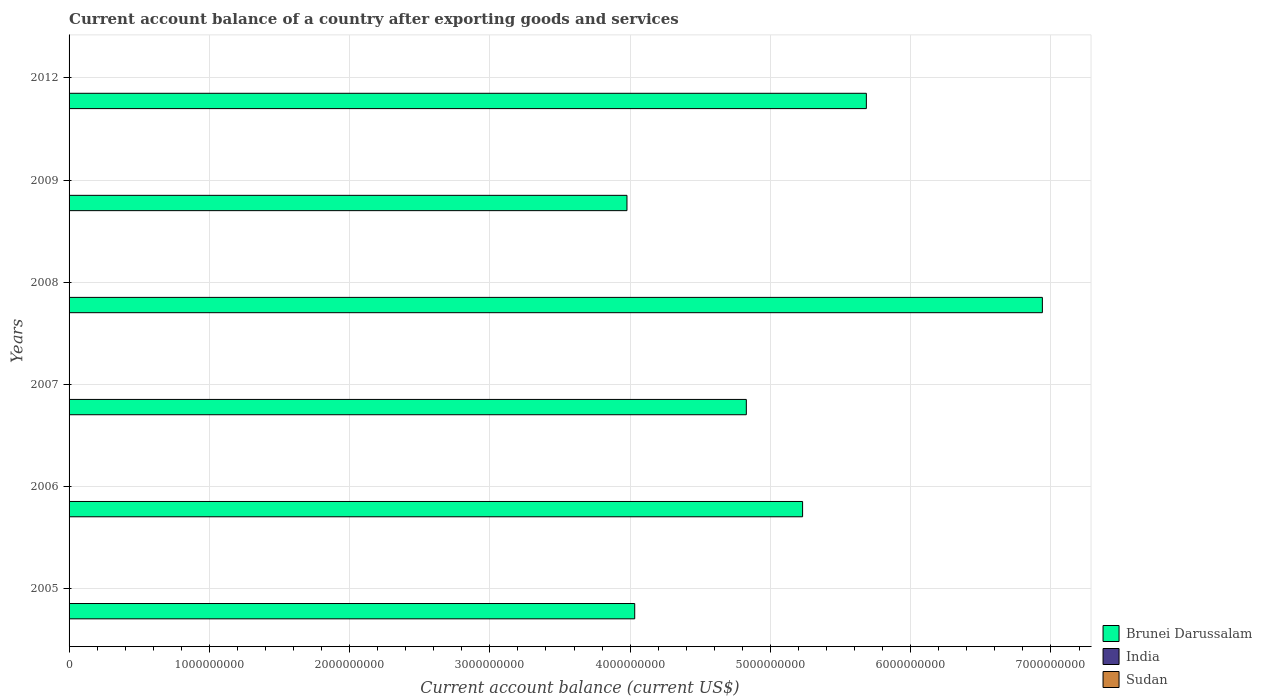How many different coloured bars are there?
Your answer should be very brief. 1. Are the number of bars per tick equal to the number of legend labels?
Make the answer very short. No. Are the number of bars on each tick of the Y-axis equal?
Give a very brief answer. Yes. How many bars are there on the 5th tick from the bottom?
Provide a short and direct response. 1. In how many cases, is the number of bars for a given year not equal to the number of legend labels?
Offer a terse response. 6. Across all years, what is the maximum account balance in Brunei Darussalam?
Provide a succinct answer. 6.94e+09. Across all years, what is the minimum account balance in Brunei Darussalam?
Make the answer very short. 3.98e+09. What is the total account balance in India in the graph?
Offer a very short reply. 0. What is the difference between the account balance in Brunei Darussalam in 2005 and that in 2006?
Your answer should be compact. -1.20e+09. What is the average account balance in Brunei Darussalam per year?
Offer a very short reply. 5.12e+09. In how many years, is the account balance in India greater than 3800000000 US$?
Keep it short and to the point. 0. What is the ratio of the account balance in Brunei Darussalam in 2006 to that in 2008?
Provide a short and direct response. 0.75. Is the account balance in Brunei Darussalam in 2007 less than that in 2009?
Your answer should be compact. No. What is the difference between the highest and the second highest account balance in Brunei Darussalam?
Your answer should be compact. 1.25e+09. What is the difference between the highest and the lowest account balance in Brunei Darussalam?
Give a very brief answer. 2.96e+09. In how many years, is the account balance in Brunei Darussalam greater than the average account balance in Brunei Darussalam taken over all years?
Offer a terse response. 3. Is it the case that in every year, the sum of the account balance in Sudan and account balance in Brunei Darussalam is greater than the account balance in India?
Offer a very short reply. Yes. Are all the bars in the graph horizontal?
Ensure brevity in your answer.  Yes. How many years are there in the graph?
Offer a terse response. 6. Are the values on the major ticks of X-axis written in scientific E-notation?
Give a very brief answer. No. Does the graph contain any zero values?
Keep it short and to the point. Yes. How are the legend labels stacked?
Provide a succinct answer. Vertical. What is the title of the graph?
Offer a very short reply. Current account balance of a country after exporting goods and services. What is the label or title of the X-axis?
Offer a terse response. Current account balance (current US$). What is the Current account balance (current US$) of Brunei Darussalam in 2005?
Ensure brevity in your answer.  4.03e+09. What is the Current account balance (current US$) of Brunei Darussalam in 2006?
Give a very brief answer. 5.23e+09. What is the Current account balance (current US$) of Sudan in 2006?
Ensure brevity in your answer.  0. What is the Current account balance (current US$) in Brunei Darussalam in 2007?
Make the answer very short. 4.83e+09. What is the Current account balance (current US$) in India in 2007?
Give a very brief answer. 0. What is the Current account balance (current US$) in Sudan in 2007?
Provide a short and direct response. 0. What is the Current account balance (current US$) of Brunei Darussalam in 2008?
Make the answer very short. 6.94e+09. What is the Current account balance (current US$) of India in 2008?
Offer a very short reply. 0. What is the Current account balance (current US$) of Brunei Darussalam in 2009?
Provide a succinct answer. 3.98e+09. What is the Current account balance (current US$) in India in 2009?
Ensure brevity in your answer.  0. What is the Current account balance (current US$) of Brunei Darussalam in 2012?
Your answer should be very brief. 5.68e+09. What is the Current account balance (current US$) in India in 2012?
Offer a very short reply. 0. What is the Current account balance (current US$) of Sudan in 2012?
Keep it short and to the point. 0. Across all years, what is the maximum Current account balance (current US$) of Brunei Darussalam?
Offer a very short reply. 6.94e+09. Across all years, what is the minimum Current account balance (current US$) in Brunei Darussalam?
Offer a terse response. 3.98e+09. What is the total Current account balance (current US$) in Brunei Darussalam in the graph?
Your answer should be compact. 3.07e+1. What is the total Current account balance (current US$) of India in the graph?
Your answer should be compact. 0. What is the difference between the Current account balance (current US$) in Brunei Darussalam in 2005 and that in 2006?
Your answer should be compact. -1.20e+09. What is the difference between the Current account balance (current US$) of Brunei Darussalam in 2005 and that in 2007?
Make the answer very short. -7.96e+08. What is the difference between the Current account balance (current US$) of Brunei Darussalam in 2005 and that in 2008?
Your answer should be very brief. -2.91e+09. What is the difference between the Current account balance (current US$) in Brunei Darussalam in 2005 and that in 2009?
Offer a very short reply. 5.52e+07. What is the difference between the Current account balance (current US$) in Brunei Darussalam in 2005 and that in 2012?
Offer a very short reply. -1.65e+09. What is the difference between the Current account balance (current US$) in Brunei Darussalam in 2006 and that in 2007?
Provide a succinct answer. 4.01e+08. What is the difference between the Current account balance (current US$) of Brunei Darussalam in 2006 and that in 2008?
Offer a very short reply. -1.71e+09. What is the difference between the Current account balance (current US$) in Brunei Darussalam in 2006 and that in 2009?
Offer a terse response. 1.25e+09. What is the difference between the Current account balance (current US$) of Brunei Darussalam in 2006 and that in 2012?
Provide a short and direct response. -4.55e+08. What is the difference between the Current account balance (current US$) of Brunei Darussalam in 2007 and that in 2008?
Provide a short and direct response. -2.11e+09. What is the difference between the Current account balance (current US$) of Brunei Darussalam in 2007 and that in 2009?
Your answer should be very brief. 8.51e+08. What is the difference between the Current account balance (current US$) of Brunei Darussalam in 2007 and that in 2012?
Offer a terse response. -8.56e+08. What is the difference between the Current account balance (current US$) of Brunei Darussalam in 2008 and that in 2009?
Offer a terse response. 2.96e+09. What is the difference between the Current account balance (current US$) in Brunei Darussalam in 2008 and that in 2012?
Your response must be concise. 1.25e+09. What is the difference between the Current account balance (current US$) of Brunei Darussalam in 2009 and that in 2012?
Make the answer very short. -1.71e+09. What is the average Current account balance (current US$) in Brunei Darussalam per year?
Your response must be concise. 5.12e+09. What is the ratio of the Current account balance (current US$) of Brunei Darussalam in 2005 to that in 2006?
Give a very brief answer. 0.77. What is the ratio of the Current account balance (current US$) of Brunei Darussalam in 2005 to that in 2007?
Your answer should be compact. 0.84. What is the ratio of the Current account balance (current US$) in Brunei Darussalam in 2005 to that in 2008?
Your answer should be very brief. 0.58. What is the ratio of the Current account balance (current US$) of Brunei Darussalam in 2005 to that in 2009?
Offer a very short reply. 1.01. What is the ratio of the Current account balance (current US$) in Brunei Darussalam in 2005 to that in 2012?
Keep it short and to the point. 0.71. What is the ratio of the Current account balance (current US$) of Brunei Darussalam in 2006 to that in 2007?
Ensure brevity in your answer.  1.08. What is the ratio of the Current account balance (current US$) of Brunei Darussalam in 2006 to that in 2008?
Provide a short and direct response. 0.75. What is the ratio of the Current account balance (current US$) in Brunei Darussalam in 2006 to that in 2009?
Your answer should be compact. 1.31. What is the ratio of the Current account balance (current US$) of Brunei Darussalam in 2007 to that in 2008?
Give a very brief answer. 0.7. What is the ratio of the Current account balance (current US$) of Brunei Darussalam in 2007 to that in 2009?
Your answer should be compact. 1.21. What is the ratio of the Current account balance (current US$) of Brunei Darussalam in 2007 to that in 2012?
Make the answer very short. 0.85. What is the ratio of the Current account balance (current US$) of Brunei Darussalam in 2008 to that in 2009?
Make the answer very short. 1.74. What is the ratio of the Current account balance (current US$) of Brunei Darussalam in 2008 to that in 2012?
Offer a terse response. 1.22. What is the ratio of the Current account balance (current US$) of Brunei Darussalam in 2009 to that in 2012?
Your response must be concise. 0.7. What is the difference between the highest and the second highest Current account balance (current US$) in Brunei Darussalam?
Give a very brief answer. 1.25e+09. What is the difference between the highest and the lowest Current account balance (current US$) of Brunei Darussalam?
Provide a short and direct response. 2.96e+09. 